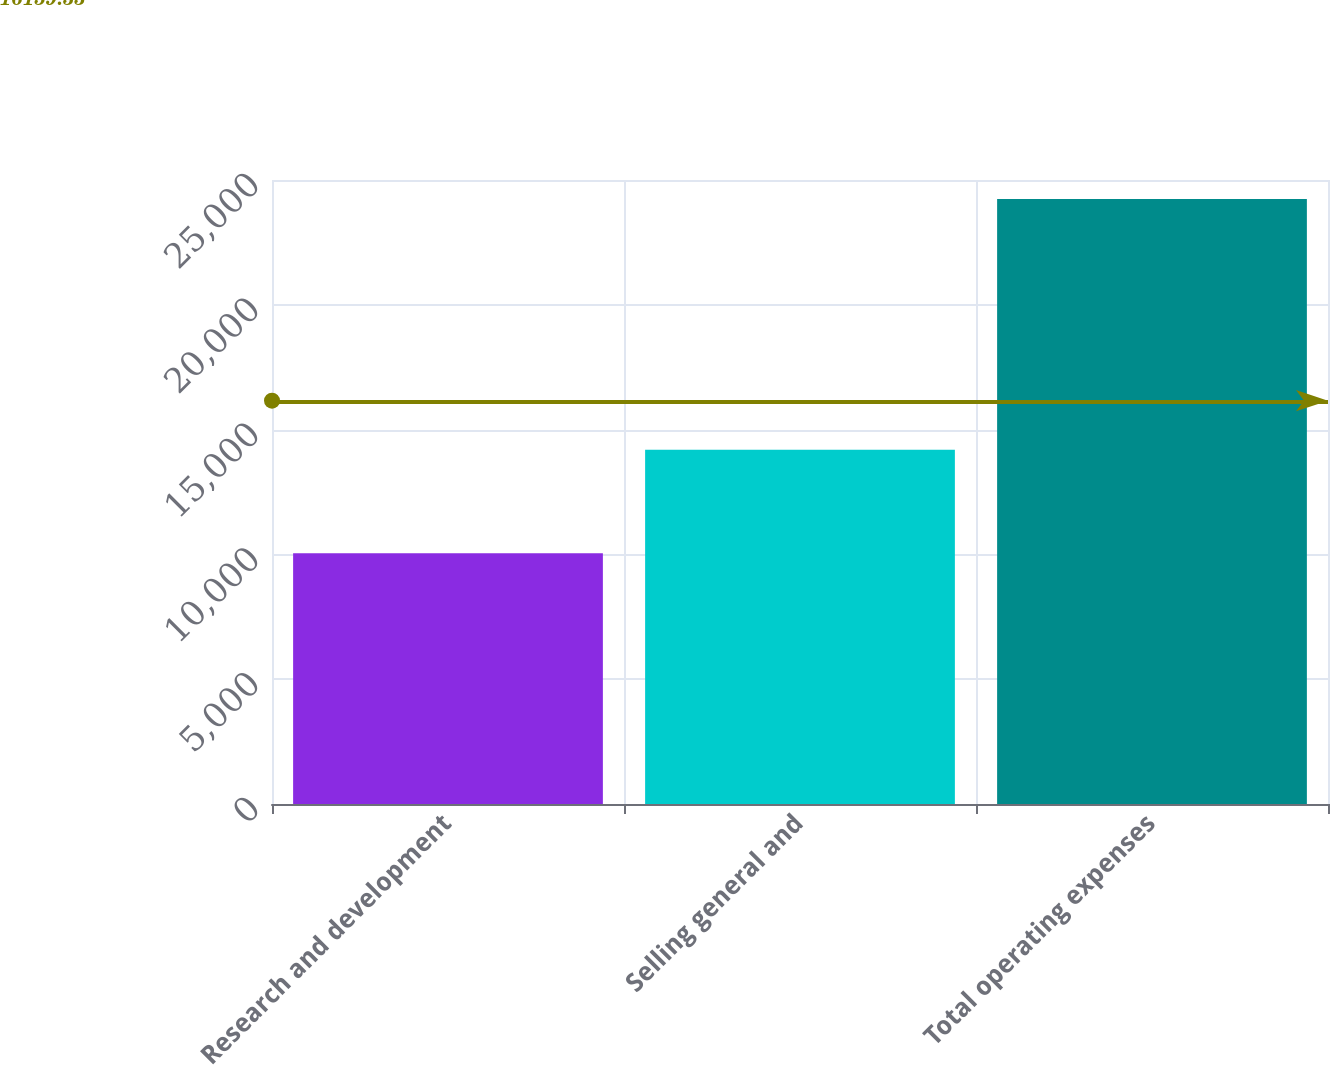<chart> <loc_0><loc_0><loc_500><loc_500><bar_chart><fcel>Research and development<fcel>Selling general and<fcel>Total operating expenses<nl><fcel>10045<fcel>14194<fcel>24239<nl></chart> 